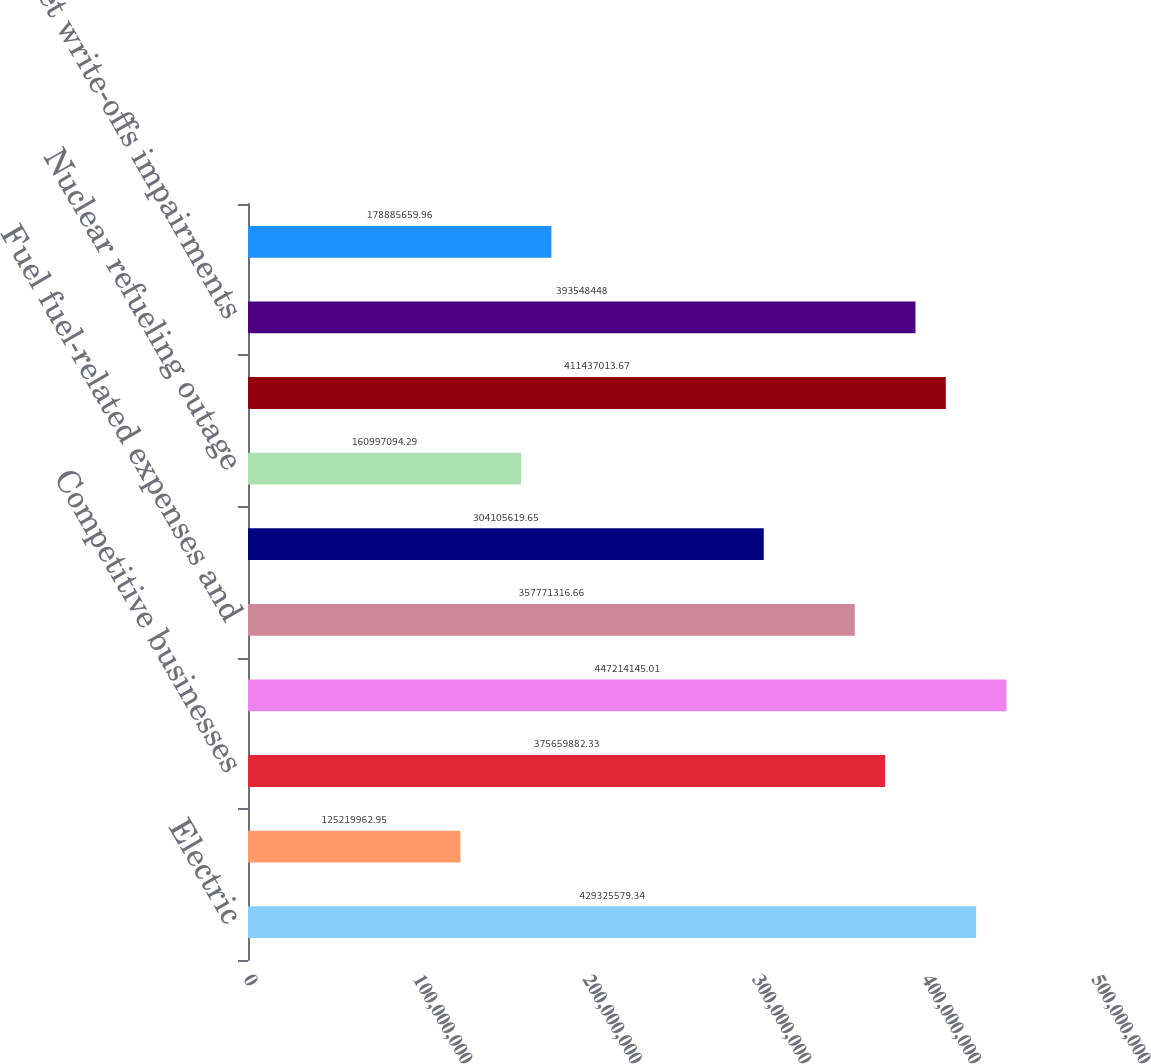Convert chart. <chart><loc_0><loc_0><loc_500><loc_500><bar_chart><fcel>Electric<fcel>Natural gas<fcel>Competitive businesses<fcel>TOTAL<fcel>Fuel fuel-related expenses and<fcel>Purchased power<fcel>Nuclear refueling outage<fcel>Other operation and<fcel>Asset write-offs impairments<fcel>Decommissioning<nl><fcel>4.29326e+08<fcel>1.2522e+08<fcel>3.7566e+08<fcel>4.47214e+08<fcel>3.57771e+08<fcel>3.04106e+08<fcel>1.60997e+08<fcel>4.11437e+08<fcel>3.93548e+08<fcel>1.78886e+08<nl></chart> 